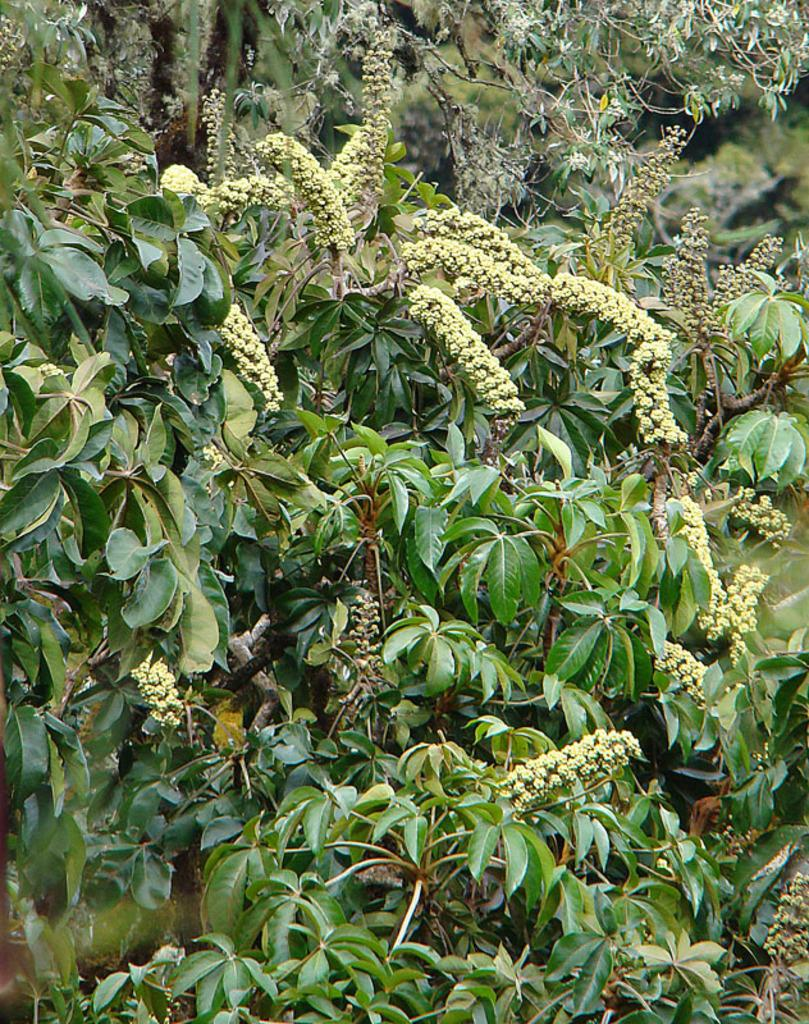What type of plant elements are visible in the image? The image contains leaves and buds of a tree. Can you describe the background of the image? There are trees in the background of the image. What is the name of the person who marked the tree in the image? There is no person or marking visible on the tree in the image. 